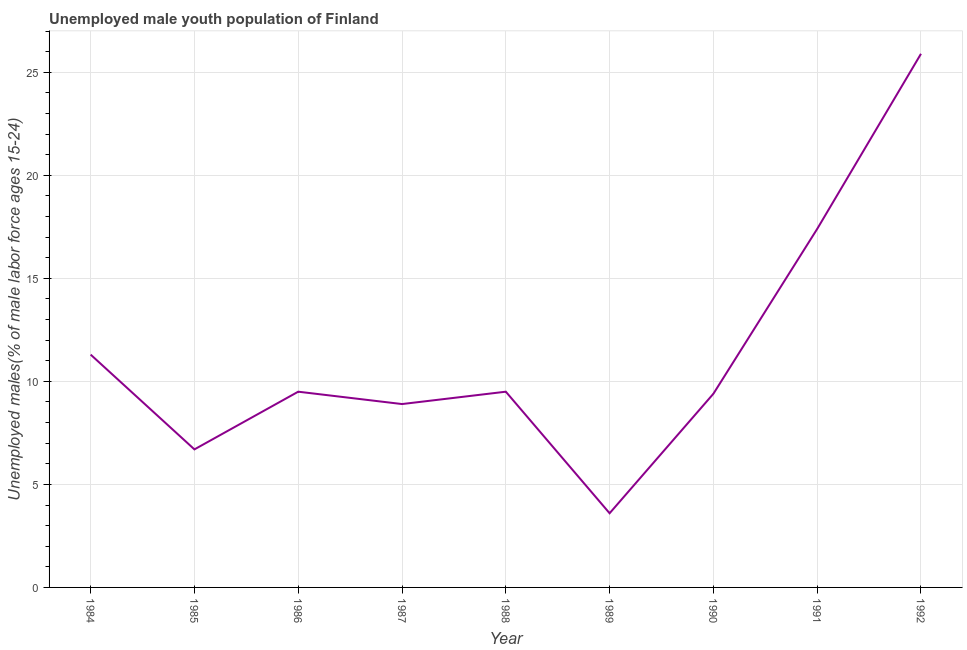Across all years, what is the maximum unemployed male youth?
Give a very brief answer. 25.9. Across all years, what is the minimum unemployed male youth?
Make the answer very short. 3.6. In which year was the unemployed male youth maximum?
Your answer should be very brief. 1992. What is the sum of the unemployed male youth?
Your answer should be compact. 102.2. What is the difference between the unemployed male youth in 1984 and 1991?
Offer a very short reply. -6.1. What is the average unemployed male youth per year?
Keep it short and to the point. 11.36. Do a majority of the years between 1987 and 1986 (inclusive) have unemployed male youth greater than 21 %?
Give a very brief answer. No. What is the ratio of the unemployed male youth in 1984 to that in 1985?
Make the answer very short. 1.69. Is the unemployed male youth in 1984 less than that in 1988?
Ensure brevity in your answer.  No. Is the difference between the unemployed male youth in 1985 and 1992 greater than the difference between any two years?
Keep it short and to the point. No. What is the difference between the highest and the second highest unemployed male youth?
Provide a succinct answer. 8.5. What is the difference between the highest and the lowest unemployed male youth?
Make the answer very short. 22.3. How many lines are there?
Your answer should be compact. 1. Are the values on the major ticks of Y-axis written in scientific E-notation?
Your response must be concise. No. Does the graph contain grids?
Provide a succinct answer. Yes. What is the title of the graph?
Your answer should be compact. Unemployed male youth population of Finland. What is the label or title of the Y-axis?
Make the answer very short. Unemployed males(% of male labor force ages 15-24). What is the Unemployed males(% of male labor force ages 15-24) in 1984?
Offer a terse response. 11.3. What is the Unemployed males(% of male labor force ages 15-24) in 1985?
Make the answer very short. 6.7. What is the Unemployed males(% of male labor force ages 15-24) in 1987?
Your answer should be very brief. 8.9. What is the Unemployed males(% of male labor force ages 15-24) in 1988?
Ensure brevity in your answer.  9.5. What is the Unemployed males(% of male labor force ages 15-24) of 1989?
Keep it short and to the point. 3.6. What is the Unemployed males(% of male labor force ages 15-24) in 1990?
Make the answer very short. 9.4. What is the Unemployed males(% of male labor force ages 15-24) in 1991?
Your response must be concise. 17.4. What is the Unemployed males(% of male labor force ages 15-24) in 1992?
Provide a short and direct response. 25.9. What is the difference between the Unemployed males(% of male labor force ages 15-24) in 1984 and 1985?
Your response must be concise. 4.6. What is the difference between the Unemployed males(% of male labor force ages 15-24) in 1984 and 1986?
Provide a short and direct response. 1.8. What is the difference between the Unemployed males(% of male labor force ages 15-24) in 1984 and 1987?
Make the answer very short. 2.4. What is the difference between the Unemployed males(% of male labor force ages 15-24) in 1984 and 1991?
Your response must be concise. -6.1. What is the difference between the Unemployed males(% of male labor force ages 15-24) in 1984 and 1992?
Keep it short and to the point. -14.6. What is the difference between the Unemployed males(% of male labor force ages 15-24) in 1985 and 1987?
Ensure brevity in your answer.  -2.2. What is the difference between the Unemployed males(% of male labor force ages 15-24) in 1985 and 1989?
Offer a terse response. 3.1. What is the difference between the Unemployed males(% of male labor force ages 15-24) in 1985 and 1992?
Give a very brief answer. -19.2. What is the difference between the Unemployed males(% of male labor force ages 15-24) in 1986 and 1988?
Give a very brief answer. 0. What is the difference between the Unemployed males(% of male labor force ages 15-24) in 1986 and 1992?
Make the answer very short. -16.4. What is the difference between the Unemployed males(% of male labor force ages 15-24) in 1987 and 1988?
Keep it short and to the point. -0.6. What is the difference between the Unemployed males(% of male labor force ages 15-24) in 1987 and 1991?
Keep it short and to the point. -8.5. What is the difference between the Unemployed males(% of male labor force ages 15-24) in 1988 and 1989?
Your response must be concise. 5.9. What is the difference between the Unemployed males(% of male labor force ages 15-24) in 1988 and 1991?
Offer a very short reply. -7.9. What is the difference between the Unemployed males(% of male labor force ages 15-24) in 1988 and 1992?
Your answer should be compact. -16.4. What is the difference between the Unemployed males(% of male labor force ages 15-24) in 1989 and 1990?
Provide a succinct answer. -5.8. What is the difference between the Unemployed males(% of male labor force ages 15-24) in 1989 and 1992?
Provide a succinct answer. -22.3. What is the difference between the Unemployed males(% of male labor force ages 15-24) in 1990 and 1991?
Provide a succinct answer. -8. What is the difference between the Unemployed males(% of male labor force ages 15-24) in 1990 and 1992?
Offer a terse response. -16.5. What is the difference between the Unemployed males(% of male labor force ages 15-24) in 1991 and 1992?
Ensure brevity in your answer.  -8.5. What is the ratio of the Unemployed males(% of male labor force ages 15-24) in 1984 to that in 1985?
Keep it short and to the point. 1.69. What is the ratio of the Unemployed males(% of male labor force ages 15-24) in 1984 to that in 1986?
Keep it short and to the point. 1.19. What is the ratio of the Unemployed males(% of male labor force ages 15-24) in 1984 to that in 1987?
Make the answer very short. 1.27. What is the ratio of the Unemployed males(% of male labor force ages 15-24) in 1984 to that in 1988?
Keep it short and to the point. 1.19. What is the ratio of the Unemployed males(% of male labor force ages 15-24) in 1984 to that in 1989?
Offer a terse response. 3.14. What is the ratio of the Unemployed males(% of male labor force ages 15-24) in 1984 to that in 1990?
Give a very brief answer. 1.2. What is the ratio of the Unemployed males(% of male labor force ages 15-24) in 1984 to that in 1991?
Your response must be concise. 0.65. What is the ratio of the Unemployed males(% of male labor force ages 15-24) in 1984 to that in 1992?
Offer a very short reply. 0.44. What is the ratio of the Unemployed males(% of male labor force ages 15-24) in 1985 to that in 1986?
Your answer should be compact. 0.7. What is the ratio of the Unemployed males(% of male labor force ages 15-24) in 1985 to that in 1987?
Your answer should be compact. 0.75. What is the ratio of the Unemployed males(% of male labor force ages 15-24) in 1985 to that in 1988?
Ensure brevity in your answer.  0.7. What is the ratio of the Unemployed males(% of male labor force ages 15-24) in 1985 to that in 1989?
Make the answer very short. 1.86. What is the ratio of the Unemployed males(% of male labor force ages 15-24) in 1985 to that in 1990?
Keep it short and to the point. 0.71. What is the ratio of the Unemployed males(% of male labor force ages 15-24) in 1985 to that in 1991?
Keep it short and to the point. 0.39. What is the ratio of the Unemployed males(% of male labor force ages 15-24) in 1985 to that in 1992?
Provide a succinct answer. 0.26. What is the ratio of the Unemployed males(% of male labor force ages 15-24) in 1986 to that in 1987?
Your answer should be very brief. 1.07. What is the ratio of the Unemployed males(% of male labor force ages 15-24) in 1986 to that in 1988?
Offer a terse response. 1. What is the ratio of the Unemployed males(% of male labor force ages 15-24) in 1986 to that in 1989?
Ensure brevity in your answer.  2.64. What is the ratio of the Unemployed males(% of male labor force ages 15-24) in 1986 to that in 1991?
Give a very brief answer. 0.55. What is the ratio of the Unemployed males(% of male labor force ages 15-24) in 1986 to that in 1992?
Make the answer very short. 0.37. What is the ratio of the Unemployed males(% of male labor force ages 15-24) in 1987 to that in 1988?
Your answer should be very brief. 0.94. What is the ratio of the Unemployed males(% of male labor force ages 15-24) in 1987 to that in 1989?
Offer a terse response. 2.47. What is the ratio of the Unemployed males(% of male labor force ages 15-24) in 1987 to that in 1990?
Provide a succinct answer. 0.95. What is the ratio of the Unemployed males(% of male labor force ages 15-24) in 1987 to that in 1991?
Give a very brief answer. 0.51. What is the ratio of the Unemployed males(% of male labor force ages 15-24) in 1987 to that in 1992?
Your answer should be very brief. 0.34. What is the ratio of the Unemployed males(% of male labor force ages 15-24) in 1988 to that in 1989?
Your answer should be very brief. 2.64. What is the ratio of the Unemployed males(% of male labor force ages 15-24) in 1988 to that in 1990?
Your answer should be very brief. 1.01. What is the ratio of the Unemployed males(% of male labor force ages 15-24) in 1988 to that in 1991?
Offer a terse response. 0.55. What is the ratio of the Unemployed males(% of male labor force ages 15-24) in 1988 to that in 1992?
Give a very brief answer. 0.37. What is the ratio of the Unemployed males(% of male labor force ages 15-24) in 1989 to that in 1990?
Your answer should be very brief. 0.38. What is the ratio of the Unemployed males(% of male labor force ages 15-24) in 1989 to that in 1991?
Your answer should be compact. 0.21. What is the ratio of the Unemployed males(% of male labor force ages 15-24) in 1989 to that in 1992?
Give a very brief answer. 0.14. What is the ratio of the Unemployed males(% of male labor force ages 15-24) in 1990 to that in 1991?
Your response must be concise. 0.54. What is the ratio of the Unemployed males(% of male labor force ages 15-24) in 1990 to that in 1992?
Your answer should be very brief. 0.36. What is the ratio of the Unemployed males(% of male labor force ages 15-24) in 1991 to that in 1992?
Ensure brevity in your answer.  0.67. 